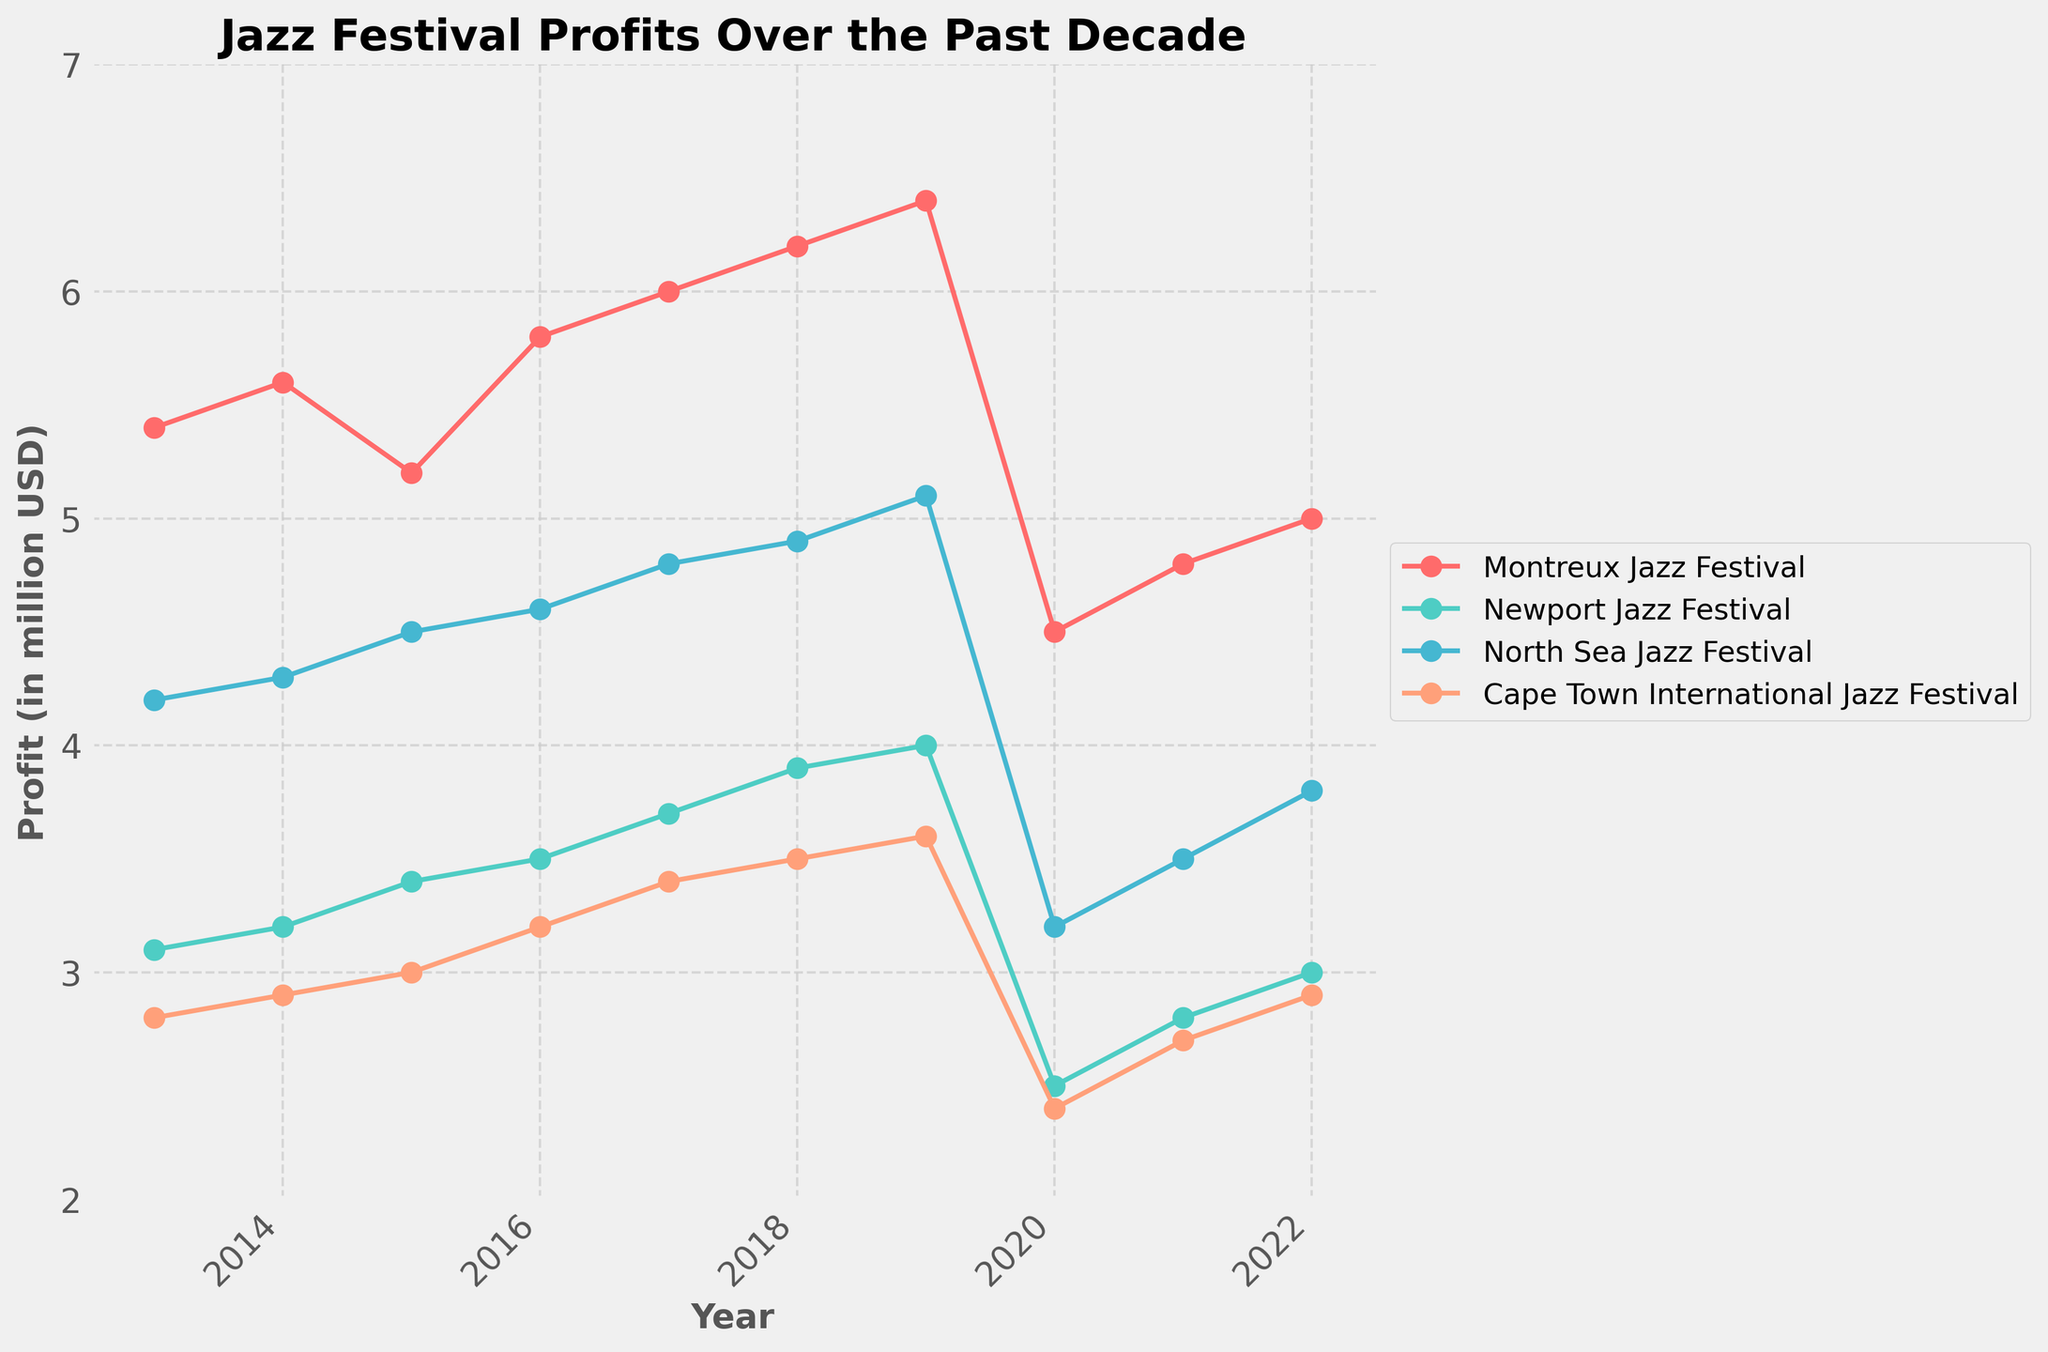What is the title of the plot? The title is placed at the top of the plot. The text "Jazz Festival Profits Over the Past Decade" is written in bold.
Answer: Jazz Festival Profits Over the Past Decade How many festivals are compared in the plot? The legend on the right side of the plot lists all the festivals compared. Each festival is represented by a different color line and marker.
Answer: Four Which festival had the highest profit in 2022? Look at the data points for the year 2022 and compare their vertical positions on the profit axis. The Montreux Jazz Festival has the highest point.
Answer: Montreux Jazz Festival What was the profit trend for the Newport Jazz Festival from 2013 to 2019? Observe the Newport Jazz Festival line from 2013 to 2019. The line generally trends upwards.
Answer: Increasing Which year shows a significant drop in profit for all the festivals? Identify the year where all the lines show a significant downward trend. This happens in 2020.
Answer: 2020 What is the difference in profit between Montreux Jazz Festival and North Sea Jazz Festival in 2020? Find the profit values for both festivals in 2020 and subtract the North Sea Jazz Festival's profit from Montreux Jazz Festival's profit (4.5 - 3.2).
Answer: 1.3 million USD Which festival had a steady increase in profits from 2013 until 2019? Examine the lines for each festival and identify the one that shows a continuous increase without major drops. The Cape Town International Jazz Festival fits this description.
Answer: Cape Town International Jazz Festival What was the average profit of the Montreux Jazz Festival from 2013 to 2019? Sum the profits of the Montreux Jazz Festival from 2013 to 2019 and divide by the number of years (5.4 + 5.6 + 5.2 + 5.8 + 6.0 + 6.2 + 6.4) / 7.
Answer: 5.8 million USD In which year was the profit for the Newport Jazz Festival seen to be lower than that of the North Sea Jazz Festival? Compare data points for both festivals year by year. In 2020, the Newport Jazz Festival's profit is lower than the North Sea Jazz Festival’s profit (2.5 vs. 3.2).
Answer: 2020 Does the plot indicate any recovery of profits after the significant drop in 2020? Look at the trends from 2020 to 2022. All festival lines show an upward trend indicating recovery.
Answer: Yes 